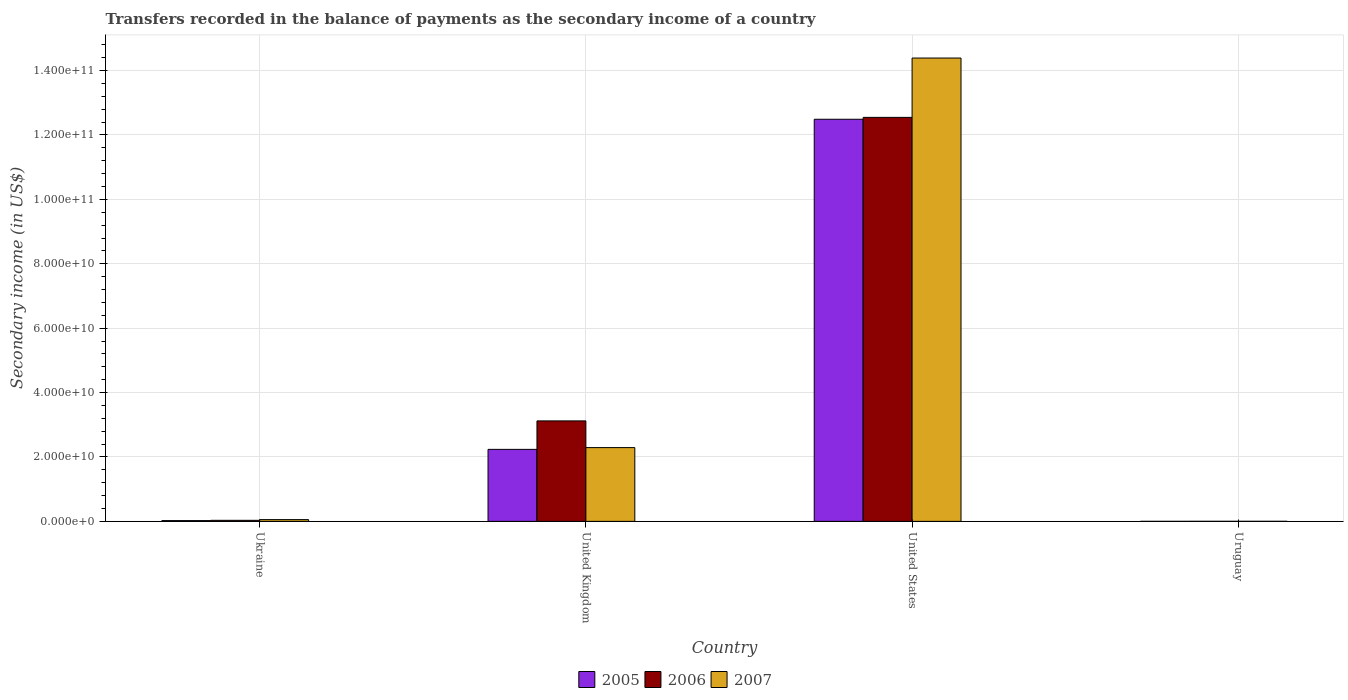How many different coloured bars are there?
Ensure brevity in your answer.  3. How many groups of bars are there?
Provide a succinct answer. 4. Are the number of bars per tick equal to the number of legend labels?
Your answer should be compact. Yes. How many bars are there on the 1st tick from the left?
Offer a terse response. 3. How many bars are there on the 3rd tick from the right?
Provide a succinct answer. 3. What is the label of the 1st group of bars from the left?
Keep it short and to the point. Ukraine. What is the secondary income of in 2006 in United States?
Make the answer very short. 1.25e+11. Across all countries, what is the maximum secondary income of in 2007?
Make the answer very short. 1.44e+11. Across all countries, what is the minimum secondary income of in 2005?
Offer a very short reply. 6.11e+06. In which country was the secondary income of in 2006 maximum?
Provide a succinct answer. United States. In which country was the secondary income of in 2007 minimum?
Keep it short and to the point. Uruguay. What is the total secondary income of in 2006 in the graph?
Make the answer very short. 1.57e+11. What is the difference between the secondary income of in 2005 in Ukraine and that in Uruguay?
Provide a succinct answer. 2.33e+08. What is the difference between the secondary income of in 2006 in United Kingdom and the secondary income of in 2005 in Uruguay?
Ensure brevity in your answer.  3.12e+1. What is the average secondary income of in 2006 per country?
Keep it short and to the point. 3.93e+1. What is the difference between the secondary income of of/in 2007 and secondary income of of/in 2006 in United Kingdom?
Your answer should be very brief. -8.29e+09. In how many countries, is the secondary income of in 2006 greater than 104000000000 US$?
Give a very brief answer. 1. What is the ratio of the secondary income of in 2005 in Ukraine to that in United Kingdom?
Your response must be concise. 0.01. What is the difference between the highest and the second highest secondary income of in 2007?
Give a very brief answer. 1.43e+11. What is the difference between the highest and the lowest secondary income of in 2005?
Make the answer very short. 1.25e+11. In how many countries, is the secondary income of in 2005 greater than the average secondary income of in 2005 taken over all countries?
Offer a very short reply. 1. Is the sum of the secondary income of in 2007 in Ukraine and Uruguay greater than the maximum secondary income of in 2005 across all countries?
Your answer should be very brief. No. What does the 3rd bar from the left in United States represents?
Keep it short and to the point. 2007. Is it the case that in every country, the sum of the secondary income of in 2005 and secondary income of in 2007 is greater than the secondary income of in 2006?
Your answer should be very brief. Yes. Are all the bars in the graph horizontal?
Your response must be concise. No. What is the difference between two consecutive major ticks on the Y-axis?
Keep it short and to the point. 2.00e+1. Are the values on the major ticks of Y-axis written in scientific E-notation?
Your answer should be very brief. Yes. Does the graph contain grids?
Ensure brevity in your answer.  Yes. Where does the legend appear in the graph?
Ensure brevity in your answer.  Bottom center. What is the title of the graph?
Make the answer very short. Transfers recorded in the balance of payments as the secondary income of a country. What is the label or title of the Y-axis?
Offer a terse response. Secondary income (in US$). What is the Secondary income (in US$) of 2005 in Ukraine?
Your answer should be very brief. 2.39e+08. What is the Secondary income (in US$) of 2006 in Ukraine?
Provide a succinct answer. 3.24e+08. What is the Secondary income (in US$) in 2007 in Ukraine?
Keep it short and to the point. 5.42e+08. What is the Secondary income (in US$) in 2005 in United Kingdom?
Your answer should be compact. 2.24e+1. What is the Secondary income (in US$) of 2006 in United Kingdom?
Provide a short and direct response. 3.12e+1. What is the Secondary income (in US$) in 2007 in United Kingdom?
Ensure brevity in your answer.  2.29e+1. What is the Secondary income (in US$) in 2005 in United States?
Keep it short and to the point. 1.25e+11. What is the Secondary income (in US$) in 2006 in United States?
Offer a terse response. 1.25e+11. What is the Secondary income (in US$) in 2007 in United States?
Give a very brief answer. 1.44e+11. What is the Secondary income (in US$) of 2005 in Uruguay?
Your response must be concise. 6.11e+06. What is the Secondary income (in US$) of 2006 in Uruguay?
Provide a short and direct response. 1.10e+07. What is the Secondary income (in US$) in 2007 in Uruguay?
Your answer should be very brief. 1.37e+07. Across all countries, what is the maximum Secondary income (in US$) in 2005?
Your response must be concise. 1.25e+11. Across all countries, what is the maximum Secondary income (in US$) of 2006?
Give a very brief answer. 1.25e+11. Across all countries, what is the maximum Secondary income (in US$) in 2007?
Ensure brevity in your answer.  1.44e+11. Across all countries, what is the minimum Secondary income (in US$) in 2005?
Give a very brief answer. 6.11e+06. Across all countries, what is the minimum Secondary income (in US$) in 2006?
Ensure brevity in your answer.  1.10e+07. Across all countries, what is the minimum Secondary income (in US$) of 2007?
Make the answer very short. 1.37e+07. What is the total Secondary income (in US$) in 2005 in the graph?
Give a very brief answer. 1.47e+11. What is the total Secondary income (in US$) of 2006 in the graph?
Your answer should be very brief. 1.57e+11. What is the total Secondary income (in US$) in 2007 in the graph?
Provide a succinct answer. 1.67e+11. What is the difference between the Secondary income (in US$) in 2005 in Ukraine and that in United Kingdom?
Your response must be concise. -2.21e+1. What is the difference between the Secondary income (in US$) of 2006 in Ukraine and that in United Kingdom?
Provide a short and direct response. -3.09e+1. What is the difference between the Secondary income (in US$) in 2007 in Ukraine and that in United Kingdom?
Provide a succinct answer. -2.24e+1. What is the difference between the Secondary income (in US$) of 2005 in Ukraine and that in United States?
Provide a succinct answer. -1.25e+11. What is the difference between the Secondary income (in US$) in 2006 in Ukraine and that in United States?
Your answer should be very brief. -1.25e+11. What is the difference between the Secondary income (in US$) in 2007 in Ukraine and that in United States?
Make the answer very short. -1.43e+11. What is the difference between the Secondary income (in US$) of 2005 in Ukraine and that in Uruguay?
Keep it short and to the point. 2.33e+08. What is the difference between the Secondary income (in US$) in 2006 in Ukraine and that in Uruguay?
Give a very brief answer. 3.13e+08. What is the difference between the Secondary income (in US$) of 2007 in Ukraine and that in Uruguay?
Offer a very short reply. 5.28e+08. What is the difference between the Secondary income (in US$) of 2005 in United Kingdom and that in United States?
Your answer should be compact. -1.03e+11. What is the difference between the Secondary income (in US$) of 2006 in United Kingdom and that in United States?
Your response must be concise. -9.43e+1. What is the difference between the Secondary income (in US$) of 2007 in United Kingdom and that in United States?
Provide a succinct answer. -1.21e+11. What is the difference between the Secondary income (in US$) in 2005 in United Kingdom and that in Uruguay?
Offer a very short reply. 2.24e+1. What is the difference between the Secondary income (in US$) in 2006 in United Kingdom and that in Uruguay?
Ensure brevity in your answer.  3.12e+1. What is the difference between the Secondary income (in US$) of 2007 in United Kingdom and that in Uruguay?
Provide a short and direct response. 2.29e+1. What is the difference between the Secondary income (in US$) in 2005 in United States and that in Uruguay?
Make the answer very short. 1.25e+11. What is the difference between the Secondary income (in US$) in 2006 in United States and that in Uruguay?
Offer a very short reply. 1.25e+11. What is the difference between the Secondary income (in US$) in 2007 in United States and that in Uruguay?
Give a very brief answer. 1.44e+11. What is the difference between the Secondary income (in US$) of 2005 in Ukraine and the Secondary income (in US$) of 2006 in United Kingdom?
Give a very brief answer. -3.10e+1. What is the difference between the Secondary income (in US$) in 2005 in Ukraine and the Secondary income (in US$) in 2007 in United Kingdom?
Provide a succinct answer. -2.27e+1. What is the difference between the Secondary income (in US$) in 2006 in Ukraine and the Secondary income (in US$) in 2007 in United Kingdom?
Your answer should be very brief. -2.26e+1. What is the difference between the Secondary income (in US$) of 2005 in Ukraine and the Secondary income (in US$) of 2006 in United States?
Give a very brief answer. -1.25e+11. What is the difference between the Secondary income (in US$) of 2005 in Ukraine and the Secondary income (in US$) of 2007 in United States?
Offer a very short reply. -1.44e+11. What is the difference between the Secondary income (in US$) in 2006 in Ukraine and the Secondary income (in US$) in 2007 in United States?
Provide a short and direct response. -1.44e+11. What is the difference between the Secondary income (in US$) in 2005 in Ukraine and the Secondary income (in US$) in 2006 in Uruguay?
Make the answer very short. 2.28e+08. What is the difference between the Secondary income (in US$) in 2005 in Ukraine and the Secondary income (in US$) in 2007 in Uruguay?
Keep it short and to the point. 2.25e+08. What is the difference between the Secondary income (in US$) in 2006 in Ukraine and the Secondary income (in US$) in 2007 in Uruguay?
Your response must be concise. 3.10e+08. What is the difference between the Secondary income (in US$) of 2005 in United Kingdom and the Secondary income (in US$) of 2006 in United States?
Give a very brief answer. -1.03e+11. What is the difference between the Secondary income (in US$) in 2005 in United Kingdom and the Secondary income (in US$) in 2007 in United States?
Give a very brief answer. -1.22e+11. What is the difference between the Secondary income (in US$) in 2006 in United Kingdom and the Secondary income (in US$) in 2007 in United States?
Your answer should be very brief. -1.13e+11. What is the difference between the Secondary income (in US$) of 2005 in United Kingdom and the Secondary income (in US$) of 2006 in Uruguay?
Your response must be concise. 2.24e+1. What is the difference between the Secondary income (in US$) of 2005 in United Kingdom and the Secondary income (in US$) of 2007 in Uruguay?
Keep it short and to the point. 2.23e+1. What is the difference between the Secondary income (in US$) of 2006 in United Kingdom and the Secondary income (in US$) of 2007 in Uruguay?
Keep it short and to the point. 3.12e+1. What is the difference between the Secondary income (in US$) in 2005 in United States and the Secondary income (in US$) in 2006 in Uruguay?
Keep it short and to the point. 1.25e+11. What is the difference between the Secondary income (in US$) in 2005 in United States and the Secondary income (in US$) in 2007 in Uruguay?
Provide a short and direct response. 1.25e+11. What is the difference between the Secondary income (in US$) of 2006 in United States and the Secondary income (in US$) of 2007 in Uruguay?
Ensure brevity in your answer.  1.25e+11. What is the average Secondary income (in US$) in 2005 per country?
Your response must be concise. 3.69e+1. What is the average Secondary income (in US$) in 2006 per country?
Make the answer very short. 3.93e+1. What is the average Secondary income (in US$) of 2007 per country?
Your answer should be compact. 4.18e+1. What is the difference between the Secondary income (in US$) in 2005 and Secondary income (in US$) in 2006 in Ukraine?
Your answer should be very brief. -8.50e+07. What is the difference between the Secondary income (in US$) of 2005 and Secondary income (in US$) of 2007 in Ukraine?
Provide a succinct answer. -3.03e+08. What is the difference between the Secondary income (in US$) in 2006 and Secondary income (in US$) in 2007 in Ukraine?
Your answer should be compact. -2.18e+08. What is the difference between the Secondary income (in US$) of 2005 and Secondary income (in US$) of 2006 in United Kingdom?
Ensure brevity in your answer.  -8.84e+09. What is the difference between the Secondary income (in US$) in 2005 and Secondary income (in US$) in 2007 in United Kingdom?
Provide a succinct answer. -5.48e+08. What is the difference between the Secondary income (in US$) of 2006 and Secondary income (in US$) of 2007 in United Kingdom?
Provide a succinct answer. 8.29e+09. What is the difference between the Secondary income (in US$) of 2005 and Secondary income (in US$) of 2006 in United States?
Your answer should be very brief. -5.83e+08. What is the difference between the Secondary income (in US$) in 2005 and Secondary income (in US$) in 2007 in United States?
Your answer should be very brief. -1.90e+1. What is the difference between the Secondary income (in US$) in 2006 and Secondary income (in US$) in 2007 in United States?
Your response must be concise. -1.84e+1. What is the difference between the Secondary income (in US$) in 2005 and Secondary income (in US$) in 2006 in Uruguay?
Keep it short and to the point. -4.93e+06. What is the difference between the Secondary income (in US$) in 2005 and Secondary income (in US$) in 2007 in Uruguay?
Your response must be concise. -7.60e+06. What is the difference between the Secondary income (in US$) of 2006 and Secondary income (in US$) of 2007 in Uruguay?
Give a very brief answer. -2.67e+06. What is the ratio of the Secondary income (in US$) in 2005 in Ukraine to that in United Kingdom?
Offer a terse response. 0.01. What is the ratio of the Secondary income (in US$) of 2006 in Ukraine to that in United Kingdom?
Your answer should be compact. 0.01. What is the ratio of the Secondary income (in US$) in 2007 in Ukraine to that in United Kingdom?
Offer a terse response. 0.02. What is the ratio of the Secondary income (in US$) in 2005 in Ukraine to that in United States?
Offer a terse response. 0. What is the ratio of the Secondary income (in US$) of 2006 in Ukraine to that in United States?
Give a very brief answer. 0. What is the ratio of the Secondary income (in US$) in 2007 in Ukraine to that in United States?
Provide a short and direct response. 0. What is the ratio of the Secondary income (in US$) in 2005 in Ukraine to that in Uruguay?
Your response must be concise. 39.12. What is the ratio of the Secondary income (in US$) in 2006 in Ukraine to that in Uruguay?
Your answer should be compact. 29.34. What is the ratio of the Secondary income (in US$) of 2007 in Ukraine to that in Uruguay?
Your answer should be compact. 39.53. What is the ratio of the Secondary income (in US$) of 2005 in United Kingdom to that in United States?
Provide a short and direct response. 0.18. What is the ratio of the Secondary income (in US$) of 2006 in United Kingdom to that in United States?
Offer a very short reply. 0.25. What is the ratio of the Secondary income (in US$) of 2007 in United Kingdom to that in United States?
Offer a very short reply. 0.16. What is the ratio of the Secondary income (in US$) in 2005 in United Kingdom to that in Uruguay?
Provide a succinct answer. 3660.45. What is the ratio of the Secondary income (in US$) in 2006 in United Kingdom to that in Uruguay?
Make the answer very short. 2825.35. What is the ratio of the Secondary income (in US$) of 2007 in United Kingdom to that in Uruguay?
Your response must be concise. 1670.79. What is the ratio of the Secondary income (in US$) of 2005 in United States to that in Uruguay?
Provide a short and direct response. 2.04e+04. What is the ratio of the Secondary income (in US$) in 2006 in United States to that in Uruguay?
Keep it short and to the point. 1.14e+04. What is the ratio of the Secondary income (in US$) of 2007 in United States to that in Uruguay?
Keep it short and to the point. 1.05e+04. What is the difference between the highest and the second highest Secondary income (in US$) of 2005?
Your response must be concise. 1.03e+11. What is the difference between the highest and the second highest Secondary income (in US$) of 2006?
Keep it short and to the point. 9.43e+1. What is the difference between the highest and the second highest Secondary income (in US$) of 2007?
Keep it short and to the point. 1.21e+11. What is the difference between the highest and the lowest Secondary income (in US$) of 2005?
Give a very brief answer. 1.25e+11. What is the difference between the highest and the lowest Secondary income (in US$) of 2006?
Provide a succinct answer. 1.25e+11. What is the difference between the highest and the lowest Secondary income (in US$) of 2007?
Provide a short and direct response. 1.44e+11. 